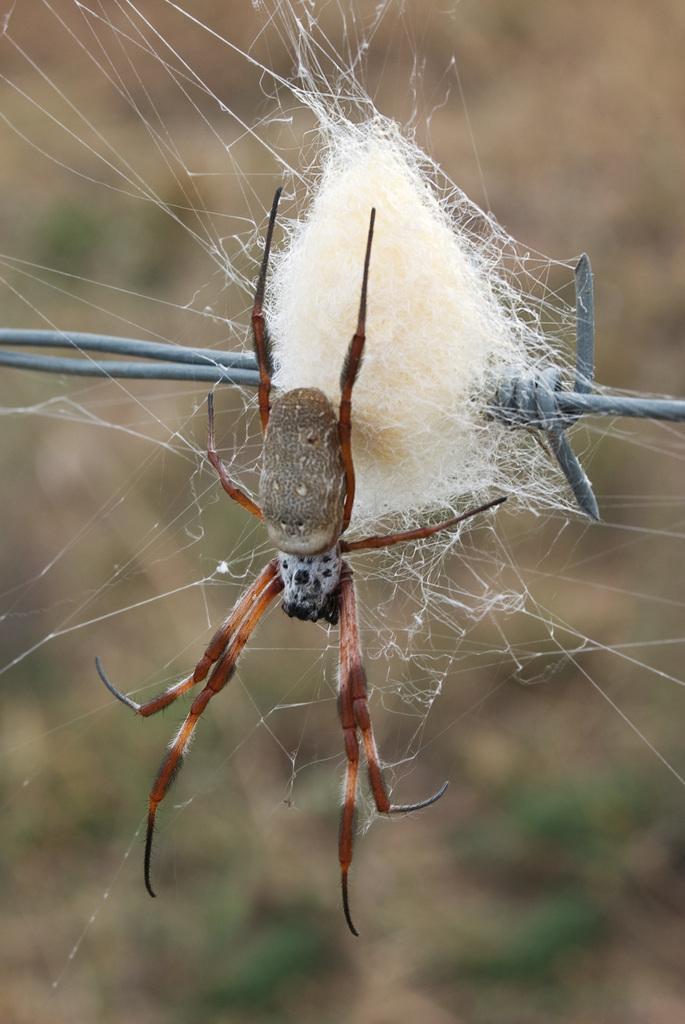In one or two sentences, can you explain what this image depicts? In the middle of the image we can see a spider on a fencing. Background of the image is blur. 